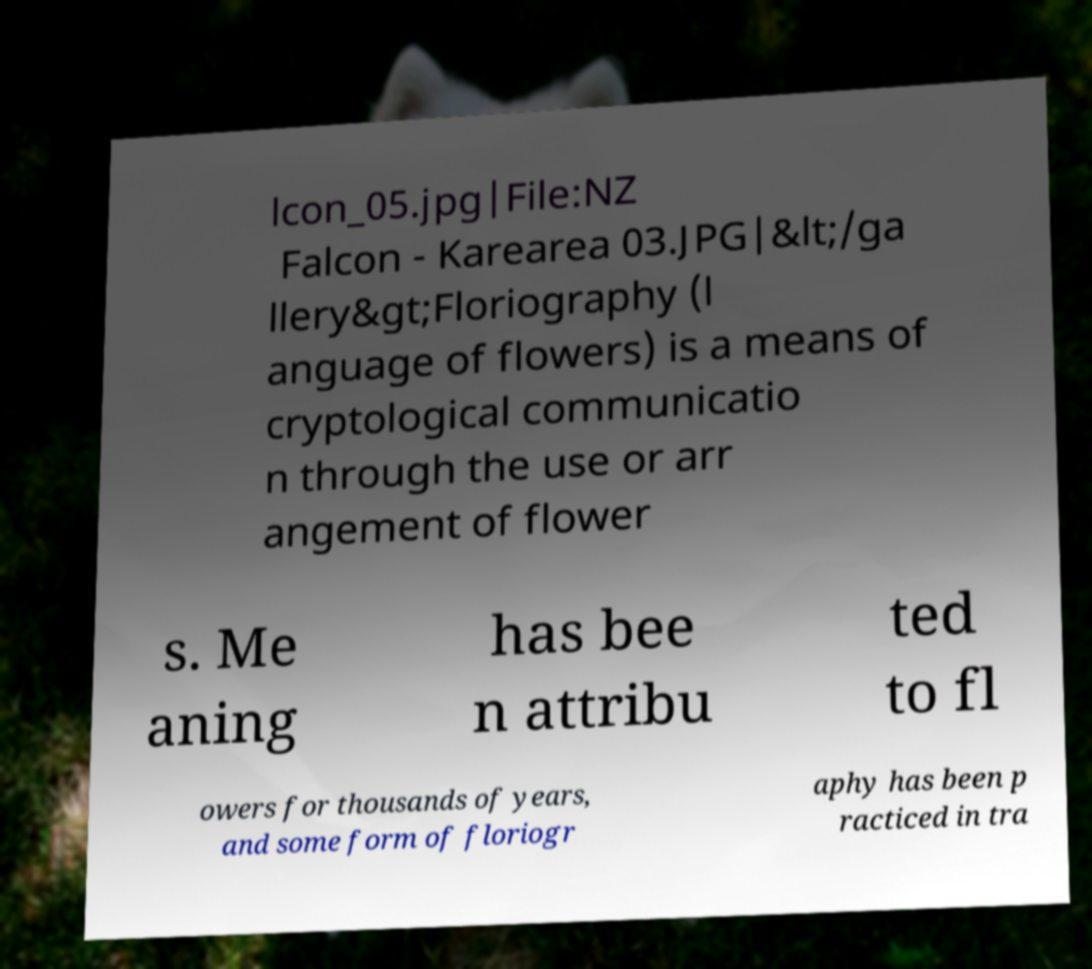What messages or text are displayed in this image? I need them in a readable, typed format. lcon_05.jpg|File:NZ Falcon - Karearea 03.JPG|&lt;/ga llery&gt;Floriography (l anguage of flowers) is a means of cryptological communicatio n through the use or arr angement of flower s. Me aning has bee n attribu ted to fl owers for thousands of years, and some form of floriogr aphy has been p racticed in tra 